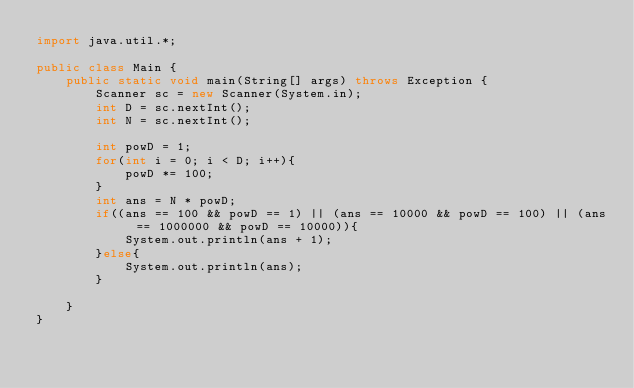Convert code to text. <code><loc_0><loc_0><loc_500><loc_500><_Java_>import java.util.*;

public class Main {
    public static void main(String[] args) throws Exception {
        Scanner sc = new Scanner(System.in);
        int D = sc.nextInt();
        int N = sc.nextInt();
        
        int powD = 1;
        for(int i = 0; i < D; i++){
            powD *= 100;
        }
        int ans = N * powD;
        if((ans == 100 && powD == 1) || (ans == 10000 && powD == 100) || (ans == 1000000 && powD == 10000)){
            System.out.println(ans + 1);
        }else{
            System.out.println(ans);
        }
        
    }
}
</code> 